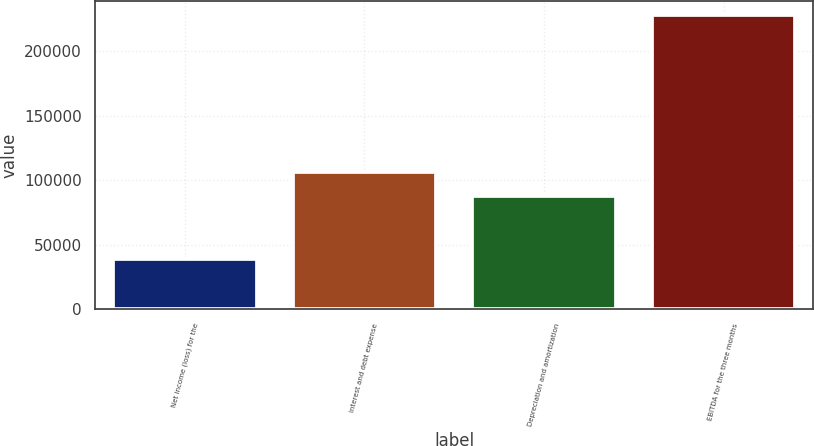Convert chart to OTSL. <chart><loc_0><loc_0><loc_500><loc_500><bar_chart><fcel>Net income (loss) for the<fcel>Interest and debt expense<fcel>Depreciation and amortization<fcel>EBITDA for the three months<nl><fcel>38742<fcel>106340<fcel>87455<fcel>227592<nl></chart> 